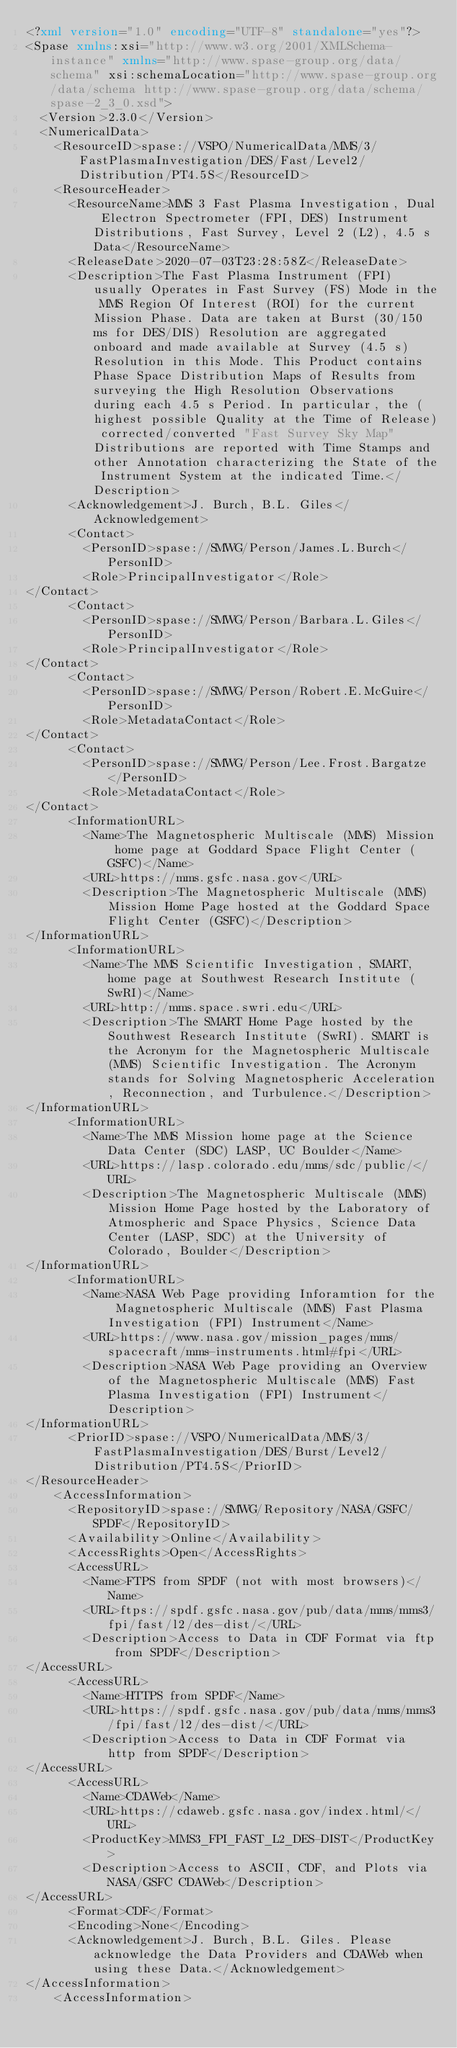Convert code to text. <code><loc_0><loc_0><loc_500><loc_500><_XML_><?xml version="1.0" encoding="UTF-8" standalone="yes"?>
<Spase xmlns:xsi="http://www.w3.org/2001/XMLSchema-instance" xmlns="http://www.spase-group.org/data/schema" xsi:schemaLocation="http://www.spase-group.org/data/schema http://www.spase-group.org/data/schema/spase-2_3_0.xsd">
  <Version>2.3.0</Version>
  <NumericalData>
    <ResourceID>spase://VSPO/NumericalData/MMS/3/FastPlasmaInvestigation/DES/Fast/Level2/Distribution/PT4.5S</ResourceID>
    <ResourceHeader>
      <ResourceName>MMS 3 Fast Plasma Investigation, Dual Electron Spectrometer (FPI, DES) Instrument Distributions, Fast Survey, Level 2 (L2), 4.5 s Data</ResourceName>
      <ReleaseDate>2020-07-03T23:28:58Z</ReleaseDate>
      <Description>The Fast Plasma Instrument (FPI) usually Operates in Fast Survey (FS) Mode in the MMS Region Of Interest (ROI) for the current Mission Phase. Data are taken at Burst (30/150 ms for DES/DIS) Resolution are aggregated onboard and made available at Survey (4.5 s) Resolution in this Mode. This Product contains Phase Space Distribution Maps of Results from surveying the High Resolution Observations during each 4.5 s Period. In particular, the (highest possible Quality at the Time of Release) corrected/converted "Fast Survey Sky Map" Distributions are reported with Time Stamps and other Annotation characterizing the State of the Instrument System at the indicated Time.</Description>
      <Acknowledgement>J. Burch, B.L. Giles</Acknowledgement>
      <Contact>
        <PersonID>spase://SMWG/Person/James.L.Burch</PersonID>
        <Role>PrincipalInvestigator</Role>
</Contact>
      <Contact>
        <PersonID>spase://SMWG/Person/Barbara.L.Giles</PersonID>
        <Role>PrincipalInvestigator</Role>
</Contact>
      <Contact>
        <PersonID>spase://SMWG/Person/Robert.E.McGuire</PersonID>
        <Role>MetadataContact</Role>
</Contact>
      <Contact>
        <PersonID>spase://SMWG/Person/Lee.Frost.Bargatze</PersonID>
        <Role>MetadataContact</Role>
</Contact>
      <InformationURL>
        <Name>The Magnetospheric Multiscale (MMS) Mission home page at Goddard Space Flight Center (GSFC)</Name>
        <URL>https://mms.gsfc.nasa.gov</URL>
        <Description>The Magnetospheric Multiscale (MMS) Mission Home Page hosted at the Goddard Space Flight Center (GSFC)</Description>
</InformationURL>
      <InformationURL>
        <Name>The MMS Scientific Investigation, SMART, home page at Southwest Research Institute (SwRI)</Name>
        <URL>http://mms.space.swri.edu</URL>
        <Description>The SMART Home Page hosted by the Southwest Research Institute (SwRI). SMART is the Acronym for the Magnetospheric Multiscale (MMS) Scientific Investigation. The Acronym stands for Solving Magnetospheric Acceleration, Reconnection, and Turbulence.</Description>
</InformationURL>
      <InformationURL>
        <Name>The MMS Mission home page at the Science Data Center (SDC) LASP, UC Boulder</Name>
        <URL>https://lasp.colorado.edu/mms/sdc/public/</URL>
        <Description>The Magnetospheric Multiscale (MMS) Mission Home Page hosted by the Laboratory of Atmospheric and Space Physics, Science Data Center (LASP, SDC) at the University of Colorado, Boulder</Description>
</InformationURL>
      <InformationURL>
        <Name>NASA Web Page providing Inforamtion for the Magnetospheric Multiscale (MMS) Fast Plasma Investigation (FPI) Instrument</Name>
        <URL>https://www.nasa.gov/mission_pages/mms/spacecraft/mms-instruments.html#fpi</URL>
        <Description>NASA Web Page providing an Overview of the Magnetospheric Multiscale (MMS) Fast Plasma Investigation (FPI) Instrument</Description>
</InformationURL>
      <PriorID>spase://VSPO/NumericalData/MMS/3/FastPlasmaInvestigation/DES/Burst/Level2/Distribution/PT4.5S</PriorID>
</ResourceHeader>
    <AccessInformation>
      <RepositoryID>spase://SMWG/Repository/NASA/GSFC/SPDF</RepositoryID>
      <Availability>Online</Availability>
      <AccessRights>Open</AccessRights>
      <AccessURL>
        <Name>FTPS from SPDF (not with most browsers)</Name>
        <URL>ftps://spdf.gsfc.nasa.gov/pub/data/mms/mms3/fpi/fast/l2/des-dist/</URL>
        <Description>Access to Data in CDF Format via ftp from SPDF</Description>
</AccessURL>
      <AccessURL>
        <Name>HTTPS from SPDF</Name>
        <URL>https://spdf.gsfc.nasa.gov/pub/data/mms/mms3/fpi/fast/l2/des-dist/</URL>
        <Description>Access to Data in CDF Format via http from SPDF</Description>
</AccessURL>
      <AccessURL>
        <Name>CDAWeb</Name>
        <URL>https://cdaweb.gsfc.nasa.gov/index.html/</URL>
        <ProductKey>MMS3_FPI_FAST_L2_DES-DIST</ProductKey>
        <Description>Access to ASCII, CDF, and Plots via NASA/GSFC CDAWeb</Description>
</AccessURL>
      <Format>CDF</Format>
      <Encoding>None</Encoding>
      <Acknowledgement>J. Burch, B.L. Giles. Please acknowledge the Data Providers and CDAWeb when using these Data.</Acknowledgement>
</AccessInformation>
    <AccessInformation></code> 